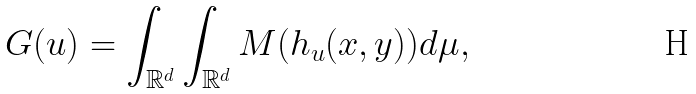Convert formula to latex. <formula><loc_0><loc_0><loc_500><loc_500>G ( u ) = \int _ { \mathbb { R } ^ { d } } \int _ { \mathbb { R } ^ { d } } M ( h _ { u } ( x , y ) ) d \mu ,</formula> 